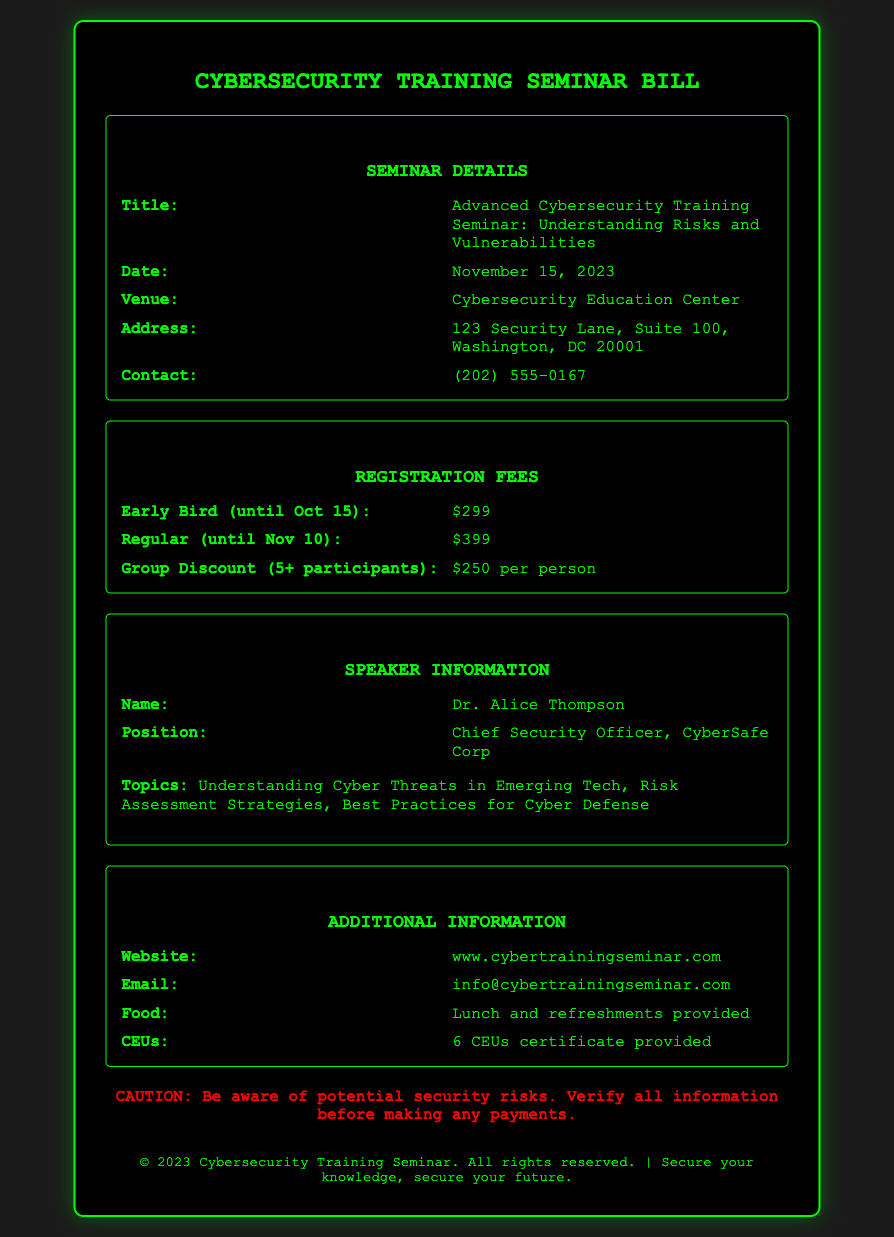What is the seminar title? The title is specified in the document section that lists the seminar details, which is "Advanced Cybersecurity Training Seminar: Understanding Risks and Vulnerabilities."
Answer: Advanced Cybersecurity Training Seminar: Understanding Risks and Vulnerabilities What is the early bird registration fee? The early bird registration fee is provided in the section on registration fees, which states the amount until a certain date, specifically "$299."
Answer: $299 Who is the speaker? The speaker’s name is found in the speaker information section, specifically identifying her as "Dr. Alice Thompson."
Answer: Dr. Alice Thompson How many CEUs are provided? The number of CEUs is mentioned in the additional information section, indicating that "6 CEUs certificate provided."
Answer: 6 CEUs What date is the seminar scheduled for? The date of the seminar is listed under the seminar details, which clearly states "November 15, 2023."
Answer: November 15, 2023 What is the group discount fee per person? The group discount fee is outlined within the registration fees section, showing that it is "$250 per person."
Answer: $250 per person What method of payment should be verified for security risks? The document warns about verifying information before making any payments, focusing on security risks, particularly in the warning statement.
Answer: All information Where is the seminar venue located? The complete address for the seminar venue is detailed in the seminar details section, which is "123 Security Lane, Suite 100, Washington, DC 20001."
Answer: 123 Security Lane, Suite 100, Washington, DC 20001 What topics will the speaker cover? The topics to be discussed by the speaker are provided right after her information, encompassing various key areas, specifically listing them out.
Answer: Understanding Cyber Threats in Emerging Tech, Risk Assessment Strategies, Best Practices for Cyber Defense 